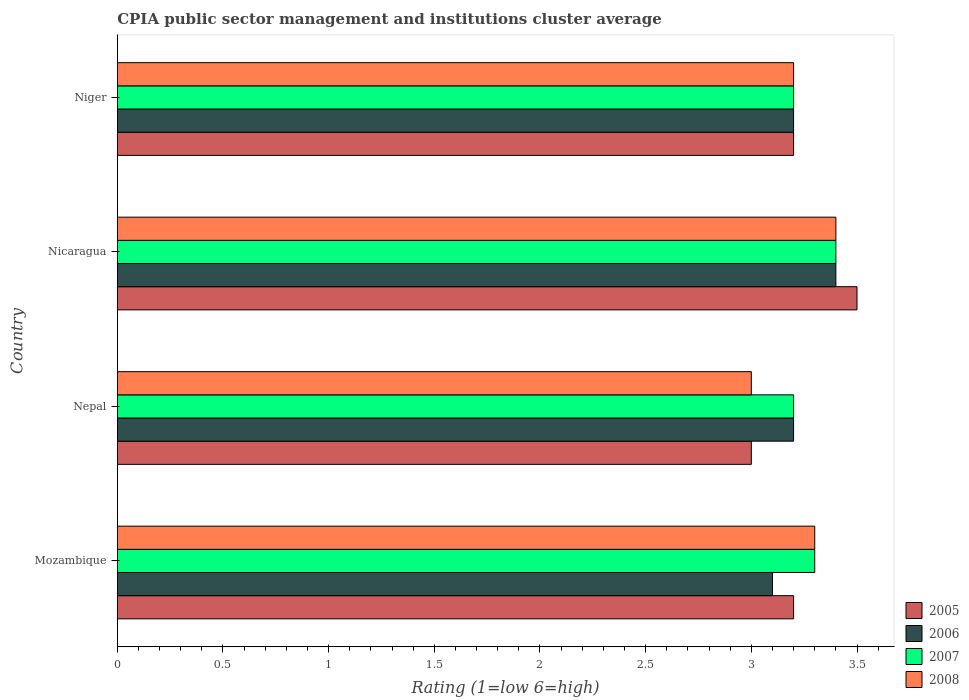How many different coloured bars are there?
Keep it short and to the point. 4. Are the number of bars per tick equal to the number of legend labels?
Your answer should be very brief. Yes. What is the label of the 2nd group of bars from the top?
Keep it short and to the point. Nicaragua. Across all countries, what is the maximum CPIA rating in 2006?
Make the answer very short. 3.4. In which country was the CPIA rating in 2008 maximum?
Offer a very short reply. Nicaragua. In which country was the CPIA rating in 2006 minimum?
Make the answer very short. Mozambique. What is the total CPIA rating in 2005 in the graph?
Your response must be concise. 12.9. What is the difference between the CPIA rating in 2005 in Nepal and that in Niger?
Ensure brevity in your answer.  -0.2. What is the difference between the CPIA rating in 2007 in Mozambique and the CPIA rating in 2005 in Nepal?
Provide a succinct answer. 0.3. What is the average CPIA rating in 2006 per country?
Your answer should be very brief. 3.23. What is the difference between the CPIA rating in 2006 and CPIA rating in 2008 in Mozambique?
Provide a succinct answer. -0.2. What is the ratio of the CPIA rating in 2008 in Nepal to that in Nicaragua?
Make the answer very short. 0.88. Is the CPIA rating in 2005 in Nepal less than that in Niger?
Provide a short and direct response. Yes. What is the difference between the highest and the second highest CPIA rating in 2007?
Give a very brief answer. 0.1. What is the difference between the highest and the lowest CPIA rating in 2006?
Make the answer very short. 0.3. Is the sum of the CPIA rating in 2007 in Nicaragua and Niger greater than the maximum CPIA rating in 2008 across all countries?
Provide a succinct answer. Yes. How many bars are there?
Keep it short and to the point. 16. Are all the bars in the graph horizontal?
Offer a very short reply. Yes. What is the difference between two consecutive major ticks on the X-axis?
Ensure brevity in your answer.  0.5. Are the values on the major ticks of X-axis written in scientific E-notation?
Ensure brevity in your answer.  No. Does the graph contain any zero values?
Offer a very short reply. No. Does the graph contain grids?
Keep it short and to the point. No. Where does the legend appear in the graph?
Provide a short and direct response. Bottom right. How many legend labels are there?
Give a very brief answer. 4. What is the title of the graph?
Your answer should be compact. CPIA public sector management and institutions cluster average. Does "1989" appear as one of the legend labels in the graph?
Make the answer very short. No. What is the Rating (1=low 6=high) in 2005 in Mozambique?
Offer a terse response. 3.2. What is the Rating (1=low 6=high) in 2007 in Mozambique?
Your answer should be very brief. 3.3. What is the Rating (1=low 6=high) in 2008 in Mozambique?
Your answer should be compact. 3.3. What is the Rating (1=low 6=high) of 2006 in Nepal?
Offer a very short reply. 3.2. What is the Rating (1=low 6=high) of 2007 in Nepal?
Provide a short and direct response. 3.2. What is the Rating (1=low 6=high) of 2005 in Niger?
Provide a succinct answer. 3.2. What is the Rating (1=low 6=high) in 2007 in Niger?
Provide a succinct answer. 3.2. What is the Rating (1=low 6=high) in 2008 in Niger?
Keep it short and to the point. 3.2. Across all countries, what is the maximum Rating (1=low 6=high) in 2005?
Ensure brevity in your answer.  3.5. Across all countries, what is the maximum Rating (1=low 6=high) of 2006?
Your answer should be very brief. 3.4. Across all countries, what is the maximum Rating (1=low 6=high) in 2008?
Your response must be concise. 3.4. Across all countries, what is the minimum Rating (1=low 6=high) of 2005?
Give a very brief answer. 3. Across all countries, what is the minimum Rating (1=low 6=high) in 2007?
Your answer should be very brief. 3.2. Across all countries, what is the minimum Rating (1=low 6=high) of 2008?
Give a very brief answer. 3. What is the total Rating (1=low 6=high) in 2005 in the graph?
Give a very brief answer. 12.9. What is the total Rating (1=low 6=high) of 2006 in the graph?
Your response must be concise. 12.9. What is the total Rating (1=low 6=high) in 2007 in the graph?
Offer a terse response. 13.1. What is the total Rating (1=low 6=high) of 2008 in the graph?
Make the answer very short. 12.9. What is the difference between the Rating (1=low 6=high) in 2005 in Mozambique and that in Nepal?
Your response must be concise. 0.2. What is the difference between the Rating (1=low 6=high) in 2007 in Mozambique and that in Nepal?
Make the answer very short. 0.1. What is the difference between the Rating (1=low 6=high) of 2008 in Mozambique and that in Nepal?
Ensure brevity in your answer.  0.3. What is the difference between the Rating (1=low 6=high) of 2006 in Mozambique and that in Nicaragua?
Your answer should be very brief. -0.3. What is the difference between the Rating (1=low 6=high) in 2007 in Mozambique and that in Nicaragua?
Give a very brief answer. -0.1. What is the difference between the Rating (1=low 6=high) in 2006 in Mozambique and that in Niger?
Your answer should be compact. -0.1. What is the difference between the Rating (1=low 6=high) of 2007 in Nepal and that in Nicaragua?
Your answer should be very brief. -0.2. What is the difference between the Rating (1=low 6=high) of 2005 in Nepal and that in Niger?
Your answer should be very brief. -0.2. What is the difference between the Rating (1=low 6=high) in 2007 in Nepal and that in Niger?
Provide a succinct answer. 0. What is the difference between the Rating (1=low 6=high) of 2005 in Nicaragua and that in Niger?
Give a very brief answer. 0.3. What is the difference between the Rating (1=low 6=high) in 2006 in Nicaragua and that in Niger?
Ensure brevity in your answer.  0.2. What is the difference between the Rating (1=low 6=high) of 2007 in Nicaragua and that in Niger?
Your response must be concise. 0.2. What is the difference between the Rating (1=low 6=high) in 2008 in Nicaragua and that in Niger?
Your answer should be very brief. 0.2. What is the difference between the Rating (1=low 6=high) in 2005 in Mozambique and the Rating (1=low 6=high) in 2006 in Nepal?
Keep it short and to the point. 0. What is the difference between the Rating (1=low 6=high) of 2006 in Mozambique and the Rating (1=low 6=high) of 2007 in Nepal?
Give a very brief answer. -0.1. What is the difference between the Rating (1=low 6=high) of 2006 in Mozambique and the Rating (1=low 6=high) of 2008 in Nepal?
Your answer should be very brief. 0.1. What is the difference between the Rating (1=low 6=high) in 2007 in Mozambique and the Rating (1=low 6=high) in 2008 in Nepal?
Keep it short and to the point. 0.3. What is the difference between the Rating (1=low 6=high) in 2005 in Mozambique and the Rating (1=low 6=high) in 2006 in Nicaragua?
Your answer should be compact. -0.2. What is the difference between the Rating (1=low 6=high) in 2005 in Mozambique and the Rating (1=low 6=high) in 2007 in Nicaragua?
Give a very brief answer. -0.2. What is the difference between the Rating (1=low 6=high) in 2006 in Mozambique and the Rating (1=low 6=high) in 2007 in Nicaragua?
Give a very brief answer. -0.3. What is the difference between the Rating (1=low 6=high) in 2007 in Mozambique and the Rating (1=low 6=high) in 2008 in Nicaragua?
Offer a very short reply. -0.1. What is the difference between the Rating (1=low 6=high) in 2005 in Mozambique and the Rating (1=low 6=high) in 2007 in Niger?
Provide a short and direct response. 0. What is the difference between the Rating (1=low 6=high) in 2005 in Mozambique and the Rating (1=low 6=high) in 2008 in Niger?
Offer a very short reply. 0. What is the difference between the Rating (1=low 6=high) in 2006 in Mozambique and the Rating (1=low 6=high) in 2008 in Niger?
Your answer should be compact. -0.1. What is the difference between the Rating (1=low 6=high) in 2005 in Nepal and the Rating (1=low 6=high) in 2006 in Nicaragua?
Give a very brief answer. -0.4. What is the difference between the Rating (1=low 6=high) of 2005 in Nepal and the Rating (1=low 6=high) of 2007 in Nicaragua?
Your answer should be very brief. -0.4. What is the difference between the Rating (1=low 6=high) of 2006 in Nepal and the Rating (1=low 6=high) of 2007 in Nicaragua?
Your answer should be very brief. -0.2. What is the difference between the Rating (1=low 6=high) in 2006 in Nepal and the Rating (1=low 6=high) in 2008 in Nicaragua?
Give a very brief answer. -0.2. What is the difference between the Rating (1=low 6=high) in 2005 in Nepal and the Rating (1=low 6=high) in 2006 in Niger?
Your answer should be compact. -0.2. What is the difference between the Rating (1=low 6=high) in 2005 in Nepal and the Rating (1=low 6=high) in 2007 in Niger?
Keep it short and to the point. -0.2. What is the difference between the Rating (1=low 6=high) of 2006 in Nepal and the Rating (1=low 6=high) of 2007 in Niger?
Make the answer very short. 0. What is the difference between the Rating (1=low 6=high) of 2006 in Nepal and the Rating (1=low 6=high) of 2008 in Niger?
Provide a succinct answer. 0. What is the difference between the Rating (1=low 6=high) of 2005 in Nicaragua and the Rating (1=low 6=high) of 2006 in Niger?
Provide a succinct answer. 0.3. What is the difference between the Rating (1=low 6=high) in 2005 in Nicaragua and the Rating (1=low 6=high) in 2007 in Niger?
Your answer should be very brief. 0.3. What is the difference between the Rating (1=low 6=high) of 2005 in Nicaragua and the Rating (1=low 6=high) of 2008 in Niger?
Your answer should be compact. 0.3. What is the difference between the Rating (1=low 6=high) of 2006 in Nicaragua and the Rating (1=low 6=high) of 2008 in Niger?
Provide a short and direct response. 0.2. What is the difference between the Rating (1=low 6=high) in 2007 in Nicaragua and the Rating (1=low 6=high) in 2008 in Niger?
Provide a succinct answer. 0.2. What is the average Rating (1=low 6=high) of 2005 per country?
Your answer should be compact. 3.23. What is the average Rating (1=low 6=high) in 2006 per country?
Give a very brief answer. 3.23. What is the average Rating (1=low 6=high) in 2007 per country?
Your answer should be very brief. 3.27. What is the average Rating (1=low 6=high) of 2008 per country?
Ensure brevity in your answer.  3.23. What is the difference between the Rating (1=low 6=high) in 2005 and Rating (1=low 6=high) in 2008 in Mozambique?
Ensure brevity in your answer.  -0.1. What is the difference between the Rating (1=low 6=high) in 2006 and Rating (1=low 6=high) in 2007 in Mozambique?
Give a very brief answer. -0.2. What is the difference between the Rating (1=low 6=high) of 2006 and Rating (1=low 6=high) of 2008 in Mozambique?
Keep it short and to the point. -0.2. What is the difference between the Rating (1=low 6=high) in 2007 and Rating (1=low 6=high) in 2008 in Mozambique?
Give a very brief answer. 0. What is the difference between the Rating (1=low 6=high) of 2005 and Rating (1=low 6=high) of 2007 in Nepal?
Make the answer very short. -0.2. What is the difference between the Rating (1=low 6=high) in 2005 and Rating (1=low 6=high) in 2008 in Nepal?
Ensure brevity in your answer.  0. What is the difference between the Rating (1=low 6=high) in 2006 and Rating (1=low 6=high) in 2007 in Nepal?
Your response must be concise. 0. What is the difference between the Rating (1=low 6=high) in 2005 and Rating (1=low 6=high) in 2006 in Nicaragua?
Give a very brief answer. 0.1. What is the difference between the Rating (1=low 6=high) of 2005 and Rating (1=low 6=high) of 2007 in Nicaragua?
Your answer should be very brief. 0.1. What is the difference between the Rating (1=low 6=high) of 2007 and Rating (1=low 6=high) of 2008 in Nicaragua?
Offer a terse response. 0. What is the difference between the Rating (1=low 6=high) of 2005 and Rating (1=low 6=high) of 2008 in Niger?
Provide a succinct answer. 0. What is the difference between the Rating (1=low 6=high) of 2006 and Rating (1=low 6=high) of 2007 in Niger?
Your answer should be very brief. 0. What is the difference between the Rating (1=low 6=high) of 2007 and Rating (1=low 6=high) of 2008 in Niger?
Your response must be concise. 0. What is the ratio of the Rating (1=low 6=high) of 2005 in Mozambique to that in Nepal?
Your response must be concise. 1.07. What is the ratio of the Rating (1=low 6=high) in 2006 in Mozambique to that in Nepal?
Offer a very short reply. 0.97. What is the ratio of the Rating (1=low 6=high) of 2007 in Mozambique to that in Nepal?
Your answer should be very brief. 1.03. What is the ratio of the Rating (1=low 6=high) in 2008 in Mozambique to that in Nepal?
Your answer should be very brief. 1.1. What is the ratio of the Rating (1=low 6=high) of 2005 in Mozambique to that in Nicaragua?
Ensure brevity in your answer.  0.91. What is the ratio of the Rating (1=low 6=high) of 2006 in Mozambique to that in Nicaragua?
Provide a succinct answer. 0.91. What is the ratio of the Rating (1=low 6=high) in 2007 in Mozambique to that in Nicaragua?
Give a very brief answer. 0.97. What is the ratio of the Rating (1=low 6=high) of 2008 in Mozambique to that in Nicaragua?
Give a very brief answer. 0.97. What is the ratio of the Rating (1=low 6=high) of 2005 in Mozambique to that in Niger?
Ensure brevity in your answer.  1. What is the ratio of the Rating (1=low 6=high) of 2006 in Mozambique to that in Niger?
Ensure brevity in your answer.  0.97. What is the ratio of the Rating (1=low 6=high) in 2007 in Mozambique to that in Niger?
Your response must be concise. 1.03. What is the ratio of the Rating (1=low 6=high) in 2008 in Mozambique to that in Niger?
Your answer should be very brief. 1.03. What is the ratio of the Rating (1=low 6=high) of 2005 in Nepal to that in Nicaragua?
Offer a terse response. 0.86. What is the ratio of the Rating (1=low 6=high) in 2008 in Nepal to that in Nicaragua?
Your answer should be very brief. 0.88. What is the ratio of the Rating (1=low 6=high) in 2008 in Nepal to that in Niger?
Provide a succinct answer. 0.94. What is the ratio of the Rating (1=low 6=high) of 2005 in Nicaragua to that in Niger?
Provide a short and direct response. 1.09. What is the ratio of the Rating (1=low 6=high) in 2008 in Nicaragua to that in Niger?
Your response must be concise. 1.06. What is the difference between the highest and the second highest Rating (1=low 6=high) in 2005?
Give a very brief answer. 0.3. What is the difference between the highest and the second highest Rating (1=low 6=high) in 2007?
Ensure brevity in your answer.  0.1. What is the difference between the highest and the second highest Rating (1=low 6=high) in 2008?
Provide a short and direct response. 0.1. What is the difference between the highest and the lowest Rating (1=low 6=high) in 2006?
Provide a short and direct response. 0.3. What is the difference between the highest and the lowest Rating (1=low 6=high) of 2007?
Your response must be concise. 0.2. 